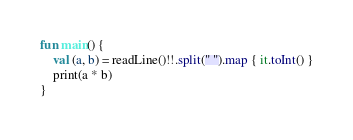<code> <loc_0><loc_0><loc_500><loc_500><_Kotlin_>fun main() {
    val (a, b) = readLine()!!.split(" ").map { it.toInt() }
    print(a * b)
}</code> 